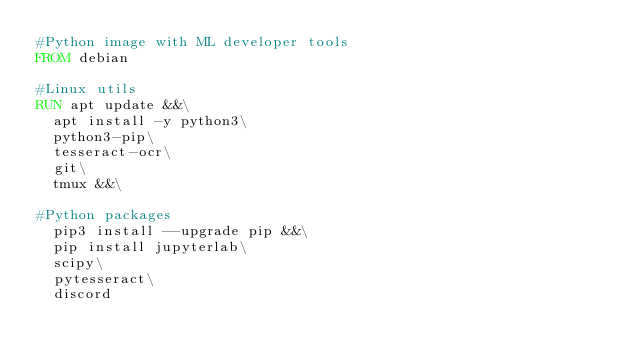<code> <loc_0><loc_0><loc_500><loc_500><_Dockerfile_>#Python image with ML developer tools
FROM debian

#Linux utils
RUN apt update &&\
  apt install -y python3\
  python3-pip\
  tesseract-ocr\
  git\
  tmux &&\
  
#Python packages
  pip3 install --upgrade pip &&\
  pip install jupyterlab\
  scipy\
  pytesseract\
  discord</code> 